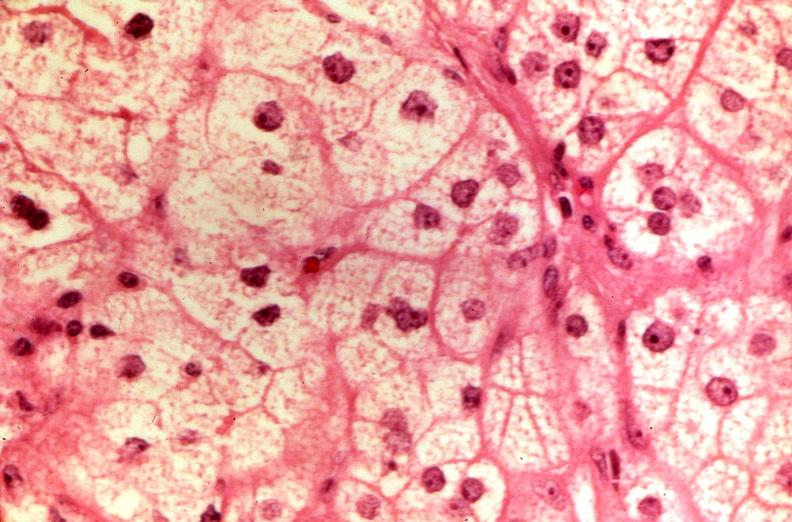what does this image show?
Answer the question using a single word or phrase. Pituitary 